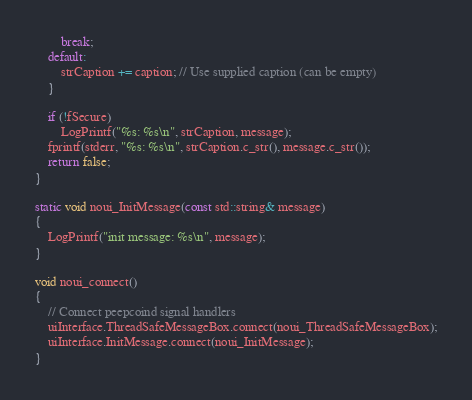Convert code to text. <code><loc_0><loc_0><loc_500><loc_500><_C++_>        break;
    default:
        strCaption += caption; // Use supplied caption (can be empty)
    }

    if (!fSecure)
        LogPrintf("%s: %s\n", strCaption, message);
    fprintf(stderr, "%s: %s\n", strCaption.c_str(), message.c_str());
    return false;
}

static void noui_InitMessage(const std::string& message)
{
    LogPrintf("init message: %s\n", message);
}

void noui_connect()
{
    // Connect peepcoind signal handlers
    uiInterface.ThreadSafeMessageBox.connect(noui_ThreadSafeMessageBox);
    uiInterface.InitMessage.connect(noui_InitMessage);
}
</code> 